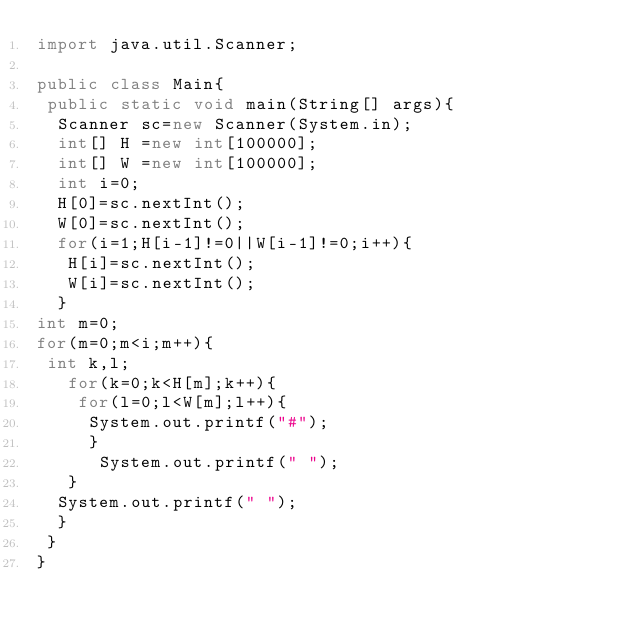Convert code to text. <code><loc_0><loc_0><loc_500><loc_500><_Java_>import java.util.Scanner;

public class Main{
 public static void main(String[] args){
  Scanner sc=new Scanner(System.in);
  int[] H =new int[100000];
  int[] W =new int[100000];
  int i=0;
  H[0]=sc.nextInt();
  W[0]=sc.nextInt();
  for(i=1;H[i-1]!=0||W[i-1]!=0;i++){
   H[i]=sc.nextInt();
   W[i]=sc.nextInt();
  }
int m=0;
for(m=0;m<i;m++){
 int k,l;
   for(k=0;k<H[m];k++){
    for(l=0;l<W[m];l++){
     System.out.printf("#");
     }
      System.out.printf(" ");
   }
  System.out.printf(" ");
  }
 }
}</code> 